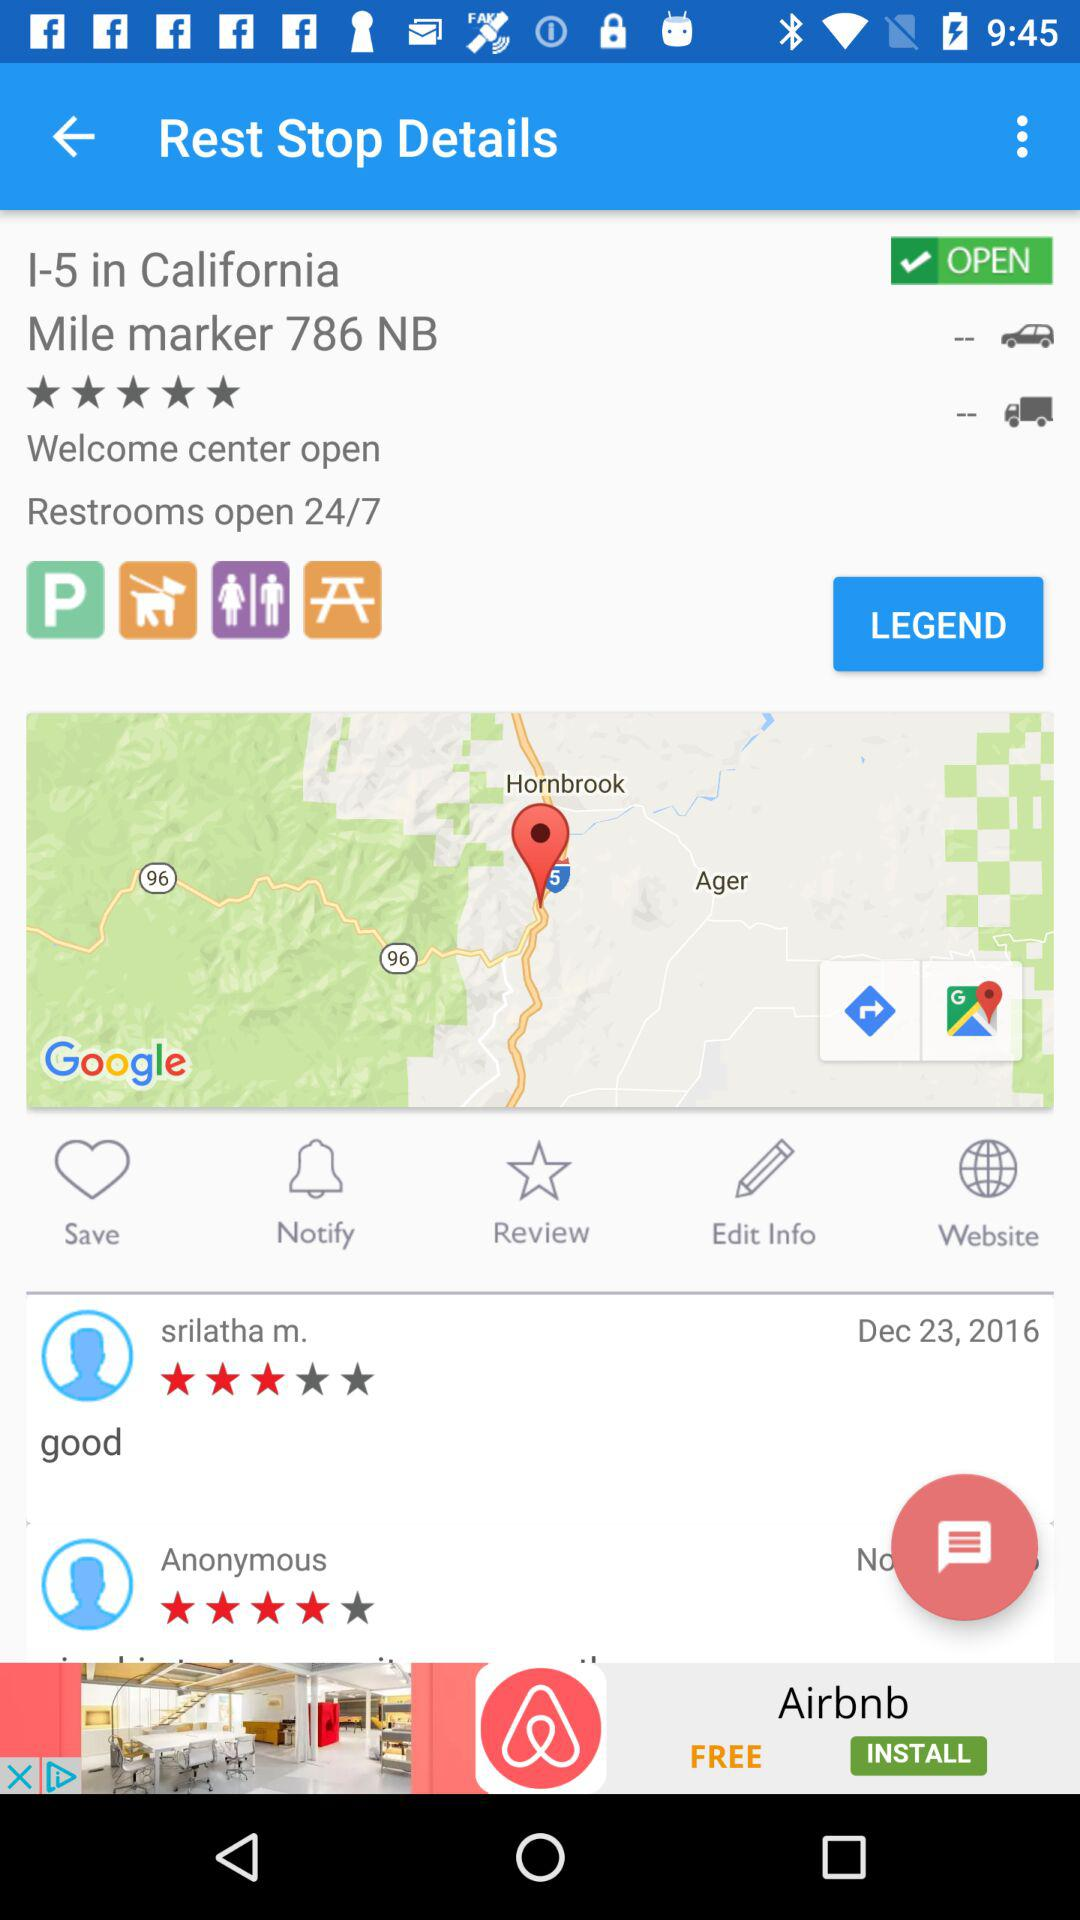How many stars did Srilatha M. give? Srilatha M. gave 3 stars. 